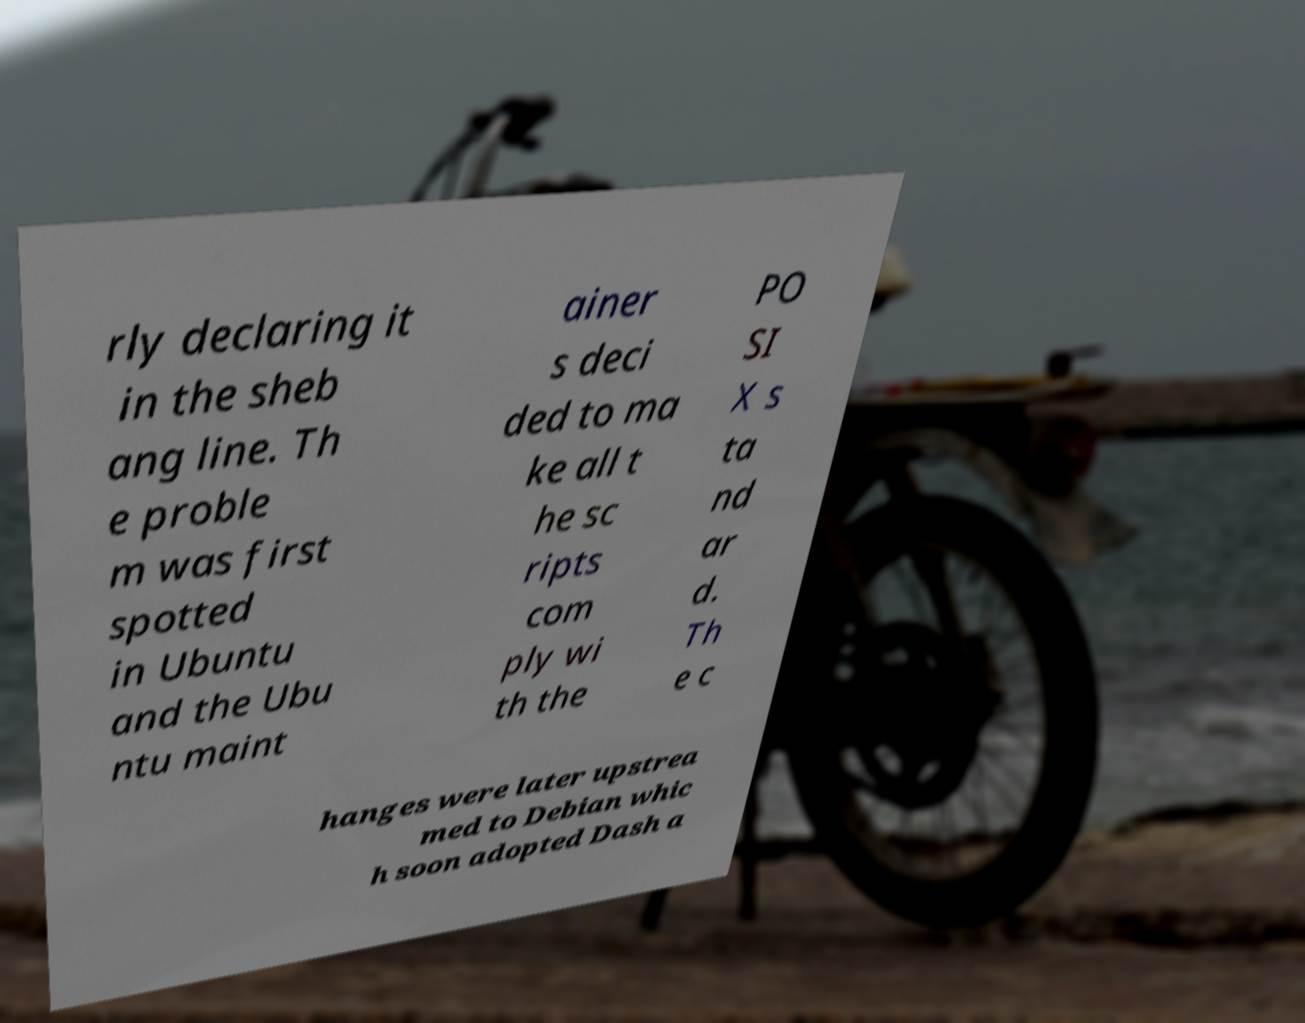Could you extract and type out the text from this image? rly declaring it in the sheb ang line. Th e proble m was first spotted in Ubuntu and the Ubu ntu maint ainer s deci ded to ma ke all t he sc ripts com ply wi th the PO SI X s ta nd ar d. Th e c hanges were later upstrea med to Debian whic h soon adopted Dash a 